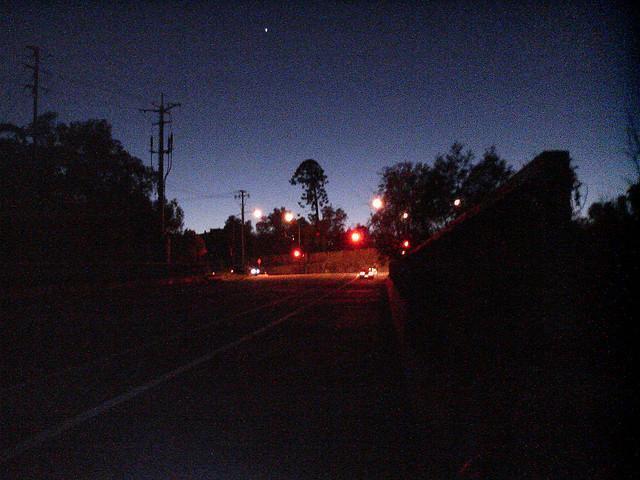How many trucks are there?
Give a very brief answer. 0. 